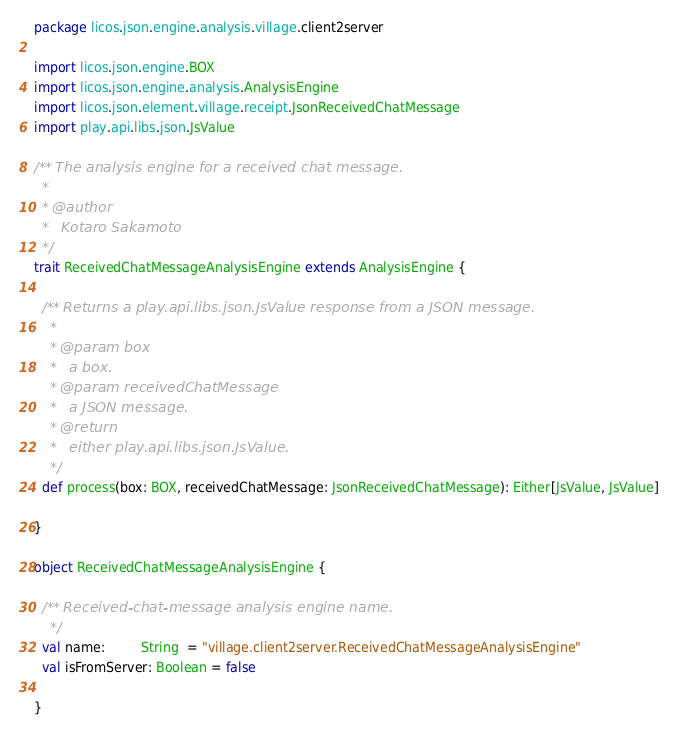<code> <loc_0><loc_0><loc_500><loc_500><_Scala_>package licos.json.engine.analysis.village.client2server

import licos.json.engine.BOX
import licos.json.engine.analysis.AnalysisEngine
import licos.json.element.village.receipt.JsonReceivedChatMessage
import play.api.libs.json.JsValue

/** The analysis engine for a received chat message.
  *
  * @author
  *   Kotaro Sakamoto
  */
trait ReceivedChatMessageAnalysisEngine extends AnalysisEngine {

  /** Returns a play.api.libs.json.JsValue response from a JSON message.
    *
    * @param box
    *   a box.
    * @param receivedChatMessage
    *   a JSON message.
    * @return
    *   either play.api.libs.json.JsValue.
    */
  def process(box: BOX, receivedChatMessage: JsonReceivedChatMessage): Either[JsValue, JsValue]

}

object ReceivedChatMessageAnalysisEngine {

  /** Received-chat-message analysis engine name.
    */
  val name:         String  = "village.client2server.ReceivedChatMessageAnalysisEngine"
  val isFromServer: Boolean = false

}
</code> 